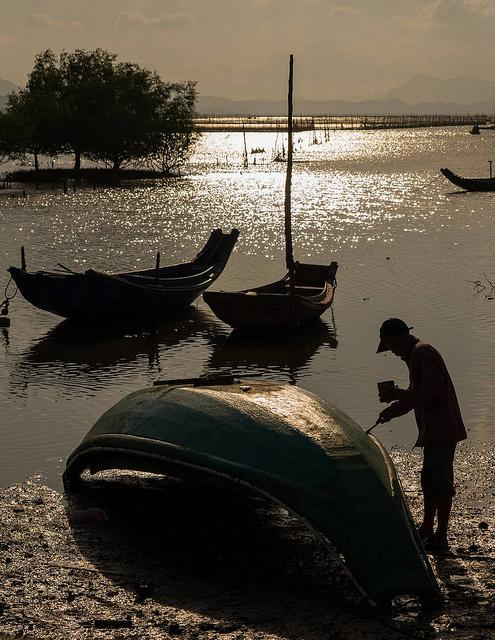What is the goal of the man working on the boat here?

Choices:
A) waterproofing
B) decorative
C) spy craft
D) weight loss waterproofing 